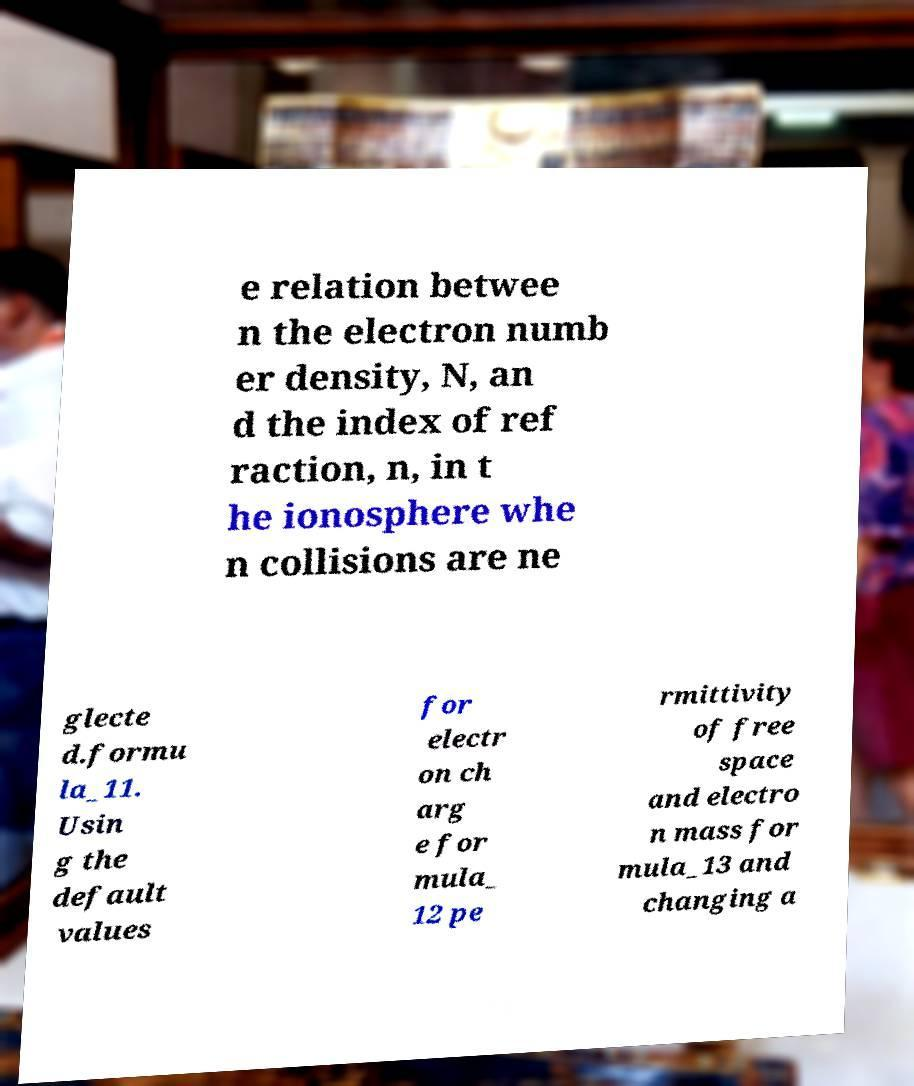There's text embedded in this image that I need extracted. Can you transcribe it verbatim? e relation betwee n the electron numb er density, N, an d the index of ref raction, n, in t he ionosphere whe n collisions are ne glecte d.formu la_11. Usin g the default values for electr on ch arg e for mula_ 12 pe rmittivity of free space and electro n mass for mula_13 and changing a 